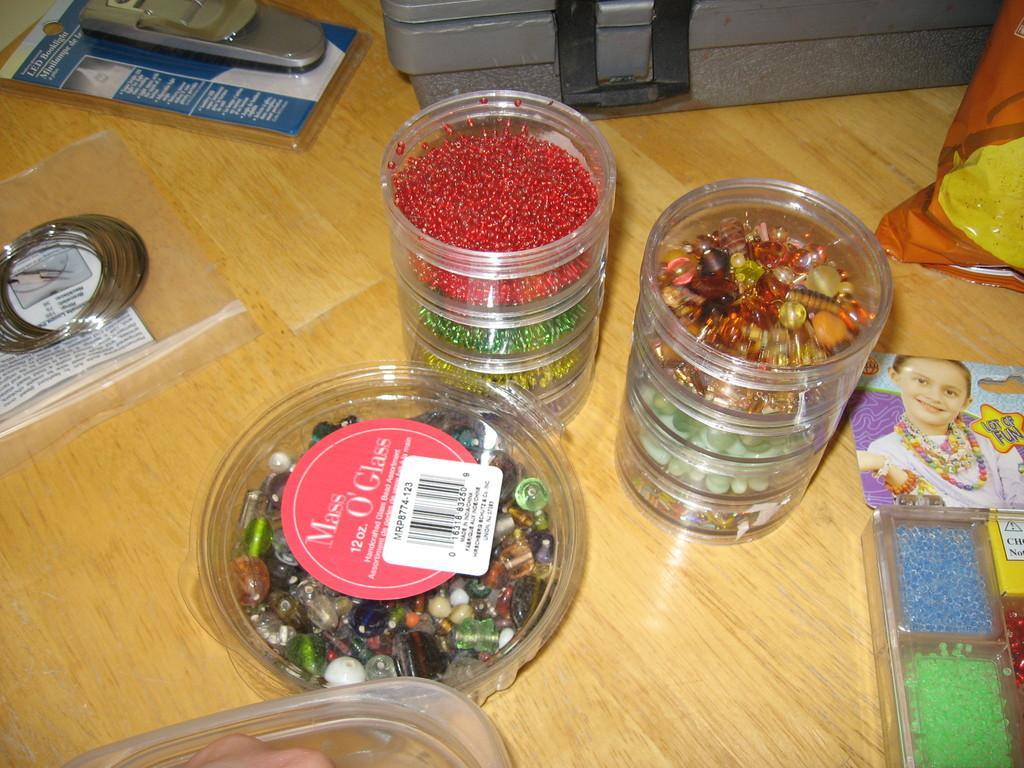Describe this image in one or two sentences. On this wooden surface there are boxes, food packed, suitcase, bangles, container and an object. In these boxes there are beads. 